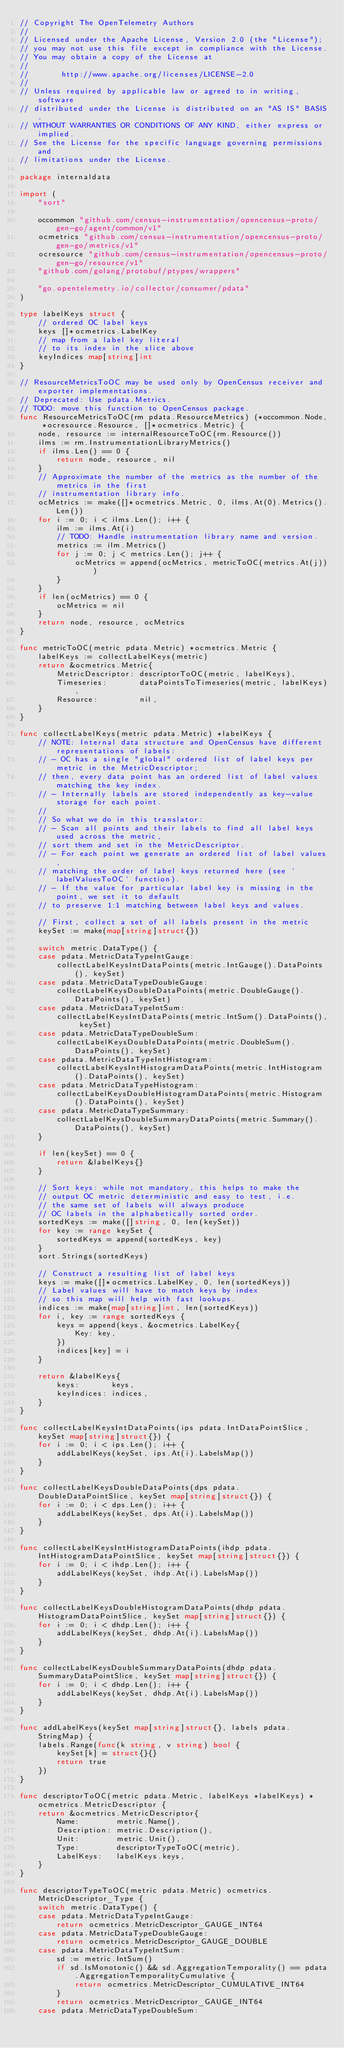Convert code to text. <code><loc_0><loc_0><loc_500><loc_500><_Go_>// Copyright The OpenTelemetry Authors
//
// Licensed under the Apache License, Version 2.0 (the "License");
// you may not use this file except in compliance with the License.
// You may obtain a copy of the License at
//
//       http://www.apache.org/licenses/LICENSE-2.0
//
// Unless required by applicable law or agreed to in writing, software
// distributed under the License is distributed on an "AS IS" BASIS,
// WITHOUT WARRANTIES OR CONDITIONS OF ANY KIND, either express or implied.
// See the License for the specific language governing permissions and
// limitations under the License.

package internaldata

import (
	"sort"

	occommon "github.com/census-instrumentation/opencensus-proto/gen-go/agent/common/v1"
	ocmetrics "github.com/census-instrumentation/opencensus-proto/gen-go/metrics/v1"
	ocresource "github.com/census-instrumentation/opencensus-proto/gen-go/resource/v1"
	"github.com/golang/protobuf/ptypes/wrappers"

	"go.opentelemetry.io/collector/consumer/pdata"
)

type labelKeys struct {
	// ordered OC label keys
	keys []*ocmetrics.LabelKey
	// map from a label key literal
	// to its index in the slice above
	keyIndices map[string]int
}

// ResourceMetricsToOC may be used only by OpenCensus receiver and exporter implementations.
// Deprecated: Use pdata.Metrics.
// TODO: move this function to OpenCensus package.
func ResourceMetricsToOC(rm pdata.ResourceMetrics) (*occommon.Node, *ocresource.Resource, []*ocmetrics.Metric) {
	node, resource := internalResourceToOC(rm.Resource())
	ilms := rm.InstrumentationLibraryMetrics()
	if ilms.Len() == 0 {
		return node, resource, nil
	}
	// Approximate the number of the metrics as the number of the metrics in the first
	// instrumentation library info.
	ocMetrics := make([]*ocmetrics.Metric, 0, ilms.At(0).Metrics().Len())
	for i := 0; i < ilms.Len(); i++ {
		ilm := ilms.At(i)
		// TODO: Handle instrumentation library name and version.
		metrics := ilm.Metrics()
		for j := 0; j < metrics.Len(); j++ {
			ocMetrics = append(ocMetrics, metricToOC(metrics.At(j)))
		}
	}
	if len(ocMetrics) == 0 {
		ocMetrics = nil
	}
	return node, resource, ocMetrics
}

func metricToOC(metric pdata.Metric) *ocmetrics.Metric {
	labelKeys := collectLabelKeys(metric)
	return &ocmetrics.Metric{
		MetricDescriptor: descriptorToOC(metric, labelKeys),
		Timeseries:       dataPointsToTimeseries(metric, labelKeys),
		Resource:         nil,
	}
}

func collectLabelKeys(metric pdata.Metric) *labelKeys {
	// NOTE: Internal data structure and OpenCensus have different representations of labels:
	// - OC has a single "global" ordered list of label keys per metric in the MetricDescriptor;
	// then, every data point has an ordered list of label values matching the key index.
	// - Internally labels are stored independently as key-value storage for each point.
	//
	// So what we do in this translator:
	// - Scan all points and their labels to find all label keys used across the metric,
	// sort them and set in the MetricDescriptor.
	// - For each point we generate an ordered list of label values,
	// matching the order of label keys returned here (see `labelValuesToOC` function).
	// - If the value for particular label key is missing in the point, we set it to default
	// to preserve 1:1 matching between label keys and values.

	// First, collect a set of all labels present in the metric
	keySet := make(map[string]struct{})

	switch metric.DataType() {
	case pdata.MetricDataTypeIntGauge:
		collectLabelKeysIntDataPoints(metric.IntGauge().DataPoints(), keySet)
	case pdata.MetricDataTypeDoubleGauge:
		collectLabelKeysDoubleDataPoints(metric.DoubleGauge().DataPoints(), keySet)
	case pdata.MetricDataTypeIntSum:
		collectLabelKeysIntDataPoints(metric.IntSum().DataPoints(), keySet)
	case pdata.MetricDataTypeDoubleSum:
		collectLabelKeysDoubleDataPoints(metric.DoubleSum().DataPoints(), keySet)
	case pdata.MetricDataTypeIntHistogram:
		collectLabelKeysIntHistogramDataPoints(metric.IntHistogram().DataPoints(), keySet)
	case pdata.MetricDataTypeHistogram:
		collectLabelKeysDoubleHistogramDataPoints(metric.Histogram().DataPoints(), keySet)
	case pdata.MetricDataTypeSummary:
		collectLabelKeysDoubleSummaryDataPoints(metric.Summary().DataPoints(), keySet)
	}

	if len(keySet) == 0 {
		return &labelKeys{}
	}

	// Sort keys: while not mandatory, this helps to make the
	// output OC metric deterministic and easy to test, i.e.
	// the same set of labels will always produce
	// OC labels in the alphabetically sorted order.
	sortedKeys := make([]string, 0, len(keySet))
	for key := range keySet {
		sortedKeys = append(sortedKeys, key)
	}
	sort.Strings(sortedKeys)

	// Construct a resulting list of label keys
	keys := make([]*ocmetrics.LabelKey, 0, len(sortedKeys))
	// Label values will have to match keys by index
	// so this map will help with fast lookups.
	indices := make(map[string]int, len(sortedKeys))
	for i, key := range sortedKeys {
		keys = append(keys, &ocmetrics.LabelKey{
			Key: key,
		})
		indices[key] = i
	}

	return &labelKeys{
		keys:       keys,
		keyIndices: indices,
	}
}

func collectLabelKeysIntDataPoints(ips pdata.IntDataPointSlice, keySet map[string]struct{}) {
	for i := 0; i < ips.Len(); i++ {
		addLabelKeys(keySet, ips.At(i).LabelsMap())
	}
}

func collectLabelKeysDoubleDataPoints(dps pdata.DoubleDataPointSlice, keySet map[string]struct{}) {
	for i := 0; i < dps.Len(); i++ {
		addLabelKeys(keySet, dps.At(i).LabelsMap())
	}
}

func collectLabelKeysIntHistogramDataPoints(ihdp pdata.IntHistogramDataPointSlice, keySet map[string]struct{}) {
	for i := 0; i < ihdp.Len(); i++ {
		addLabelKeys(keySet, ihdp.At(i).LabelsMap())
	}
}

func collectLabelKeysDoubleHistogramDataPoints(dhdp pdata.HistogramDataPointSlice, keySet map[string]struct{}) {
	for i := 0; i < dhdp.Len(); i++ {
		addLabelKeys(keySet, dhdp.At(i).LabelsMap())
	}
}

func collectLabelKeysDoubleSummaryDataPoints(dhdp pdata.SummaryDataPointSlice, keySet map[string]struct{}) {
	for i := 0; i < dhdp.Len(); i++ {
		addLabelKeys(keySet, dhdp.At(i).LabelsMap())
	}
}

func addLabelKeys(keySet map[string]struct{}, labels pdata.StringMap) {
	labels.Range(func(k string, v string) bool {
		keySet[k] = struct{}{}
		return true
	})
}

func descriptorToOC(metric pdata.Metric, labelKeys *labelKeys) *ocmetrics.MetricDescriptor {
	return &ocmetrics.MetricDescriptor{
		Name:        metric.Name(),
		Description: metric.Description(),
		Unit:        metric.Unit(),
		Type:        descriptorTypeToOC(metric),
		LabelKeys:   labelKeys.keys,
	}
}

func descriptorTypeToOC(metric pdata.Metric) ocmetrics.MetricDescriptor_Type {
	switch metric.DataType() {
	case pdata.MetricDataTypeIntGauge:
		return ocmetrics.MetricDescriptor_GAUGE_INT64
	case pdata.MetricDataTypeDoubleGauge:
		return ocmetrics.MetricDescriptor_GAUGE_DOUBLE
	case pdata.MetricDataTypeIntSum:
		sd := metric.IntSum()
		if sd.IsMonotonic() && sd.AggregationTemporality() == pdata.AggregationTemporalityCumulative {
			return ocmetrics.MetricDescriptor_CUMULATIVE_INT64
		}
		return ocmetrics.MetricDescriptor_GAUGE_INT64
	case pdata.MetricDataTypeDoubleSum:</code> 